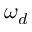<formula> <loc_0><loc_0><loc_500><loc_500>\omega _ { d }</formula> 